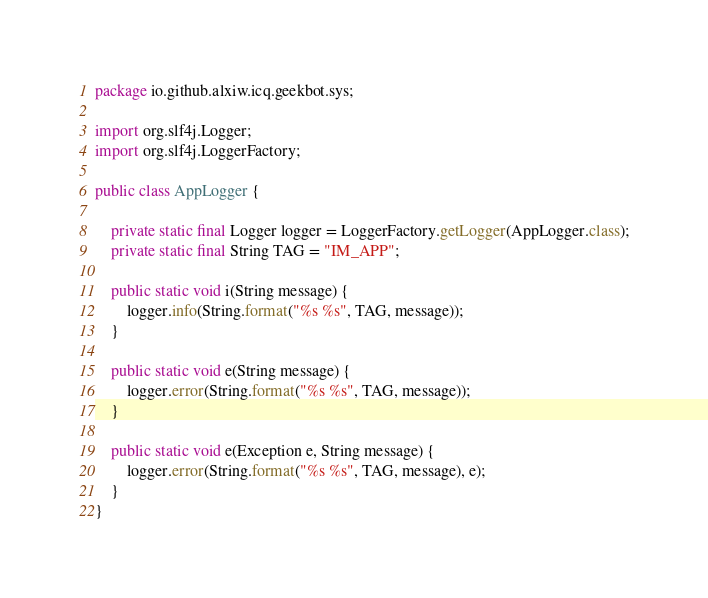<code> <loc_0><loc_0><loc_500><loc_500><_Java_>package io.github.alxiw.icq.geekbot.sys;

import org.slf4j.Logger;
import org.slf4j.LoggerFactory;

public class AppLogger {

    private static final Logger logger = LoggerFactory.getLogger(AppLogger.class);
    private static final String TAG = "IM_APP";

    public static void i(String message) {
        logger.info(String.format("%s %s", TAG, message));
    }

    public static void e(String message) {
        logger.error(String.format("%s %s", TAG, message));
    }

    public static void e(Exception e, String message) {
        logger.error(String.format("%s %s", TAG, message), e);
    }
}
</code> 